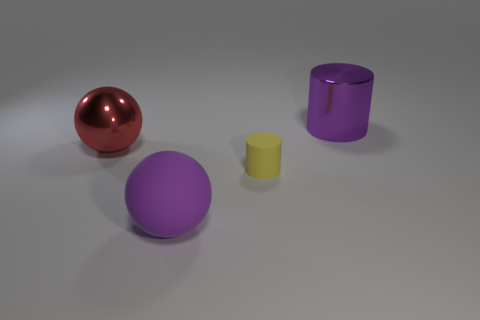What size is the cylinder that is in front of the purple metal object?
Make the answer very short. Small. There is a purple object that is the same shape as the large red metal object; what material is it?
Offer a terse response. Rubber. Is there any other thing that is the same size as the rubber cylinder?
Provide a succinct answer. No. There is a small yellow rubber object that is in front of the big purple cylinder; what shape is it?
Ensure brevity in your answer.  Cylinder. What number of yellow rubber objects have the same shape as the purple shiny object?
Give a very brief answer. 1. Are there an equal number of big objects that are in front of the small matte object and big purple matte balls left of the large matte ball?
Offer a terse response. No. Are there any large objects made of the same material as the tiny yellow cylinder?
Give a very brief answer. Yes. Is the small yellow cylinder made of the same material as the big red ball?
Offer a terse response. No. What number of cyan objects are rubber cylinders or shiny balls?
Offer a terse response. 0. Is the number of big purple objects right of the small yellow cylinder greater than the number of tiny brown metallic cubes?
Your answer should be very brief. Yes. 